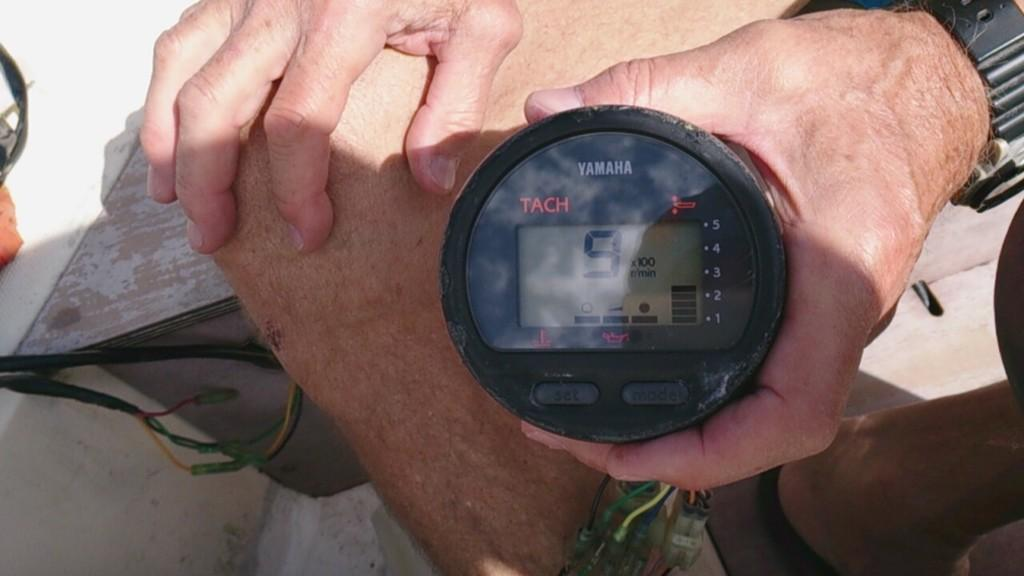<image>
Relay a brief, clear account of the picture shown. A person is holding a Yamaha device that has the number 9 in the display window. 